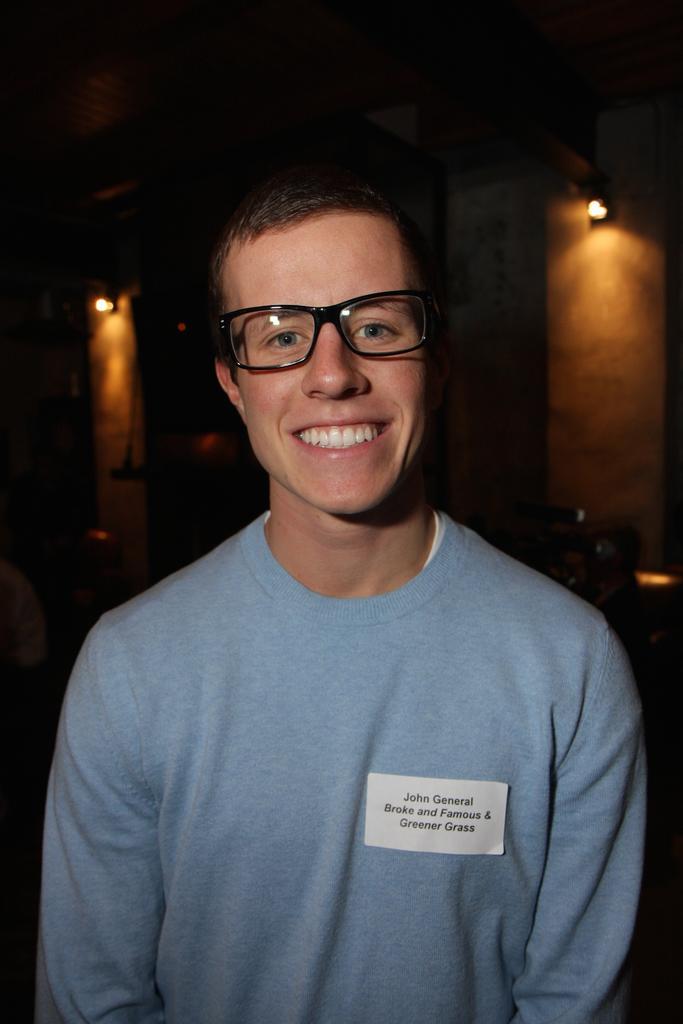Can you describe this image briefly? Here I can see a man wearing a t-shirt, spectacles, smiling and looking at the picture. On the right side there is a white paper attached to his t-shirt. On this, I can see some text. In the background there are few lights in the dark. 